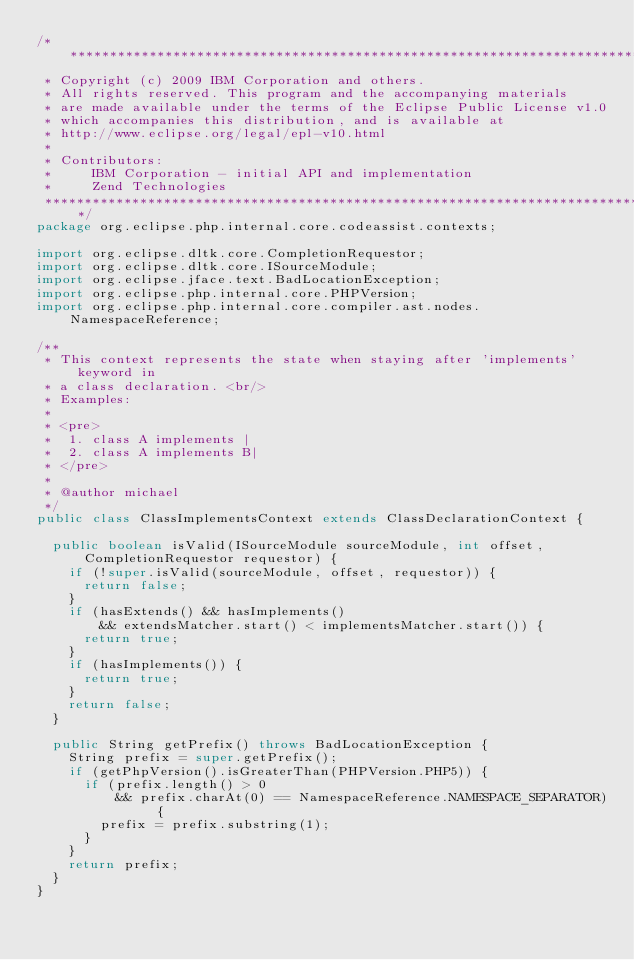Convert code to text. <code><loc_0><loc_0><loc_500><loc_500><_Java_>/*******************************************************************************
 * Copyright (c) 2009 IBM Corporation and others.
 * All rights reserved. This program and the accompanying materials
 * are made available under the terms of the Eclipse Public License v1.0
 * which accompanies this distribution, and is available at
 * http://www.eclipse.org/legal/epl-v10.html
 * 
 * Contributors:
 *     IBM Corporation - initial API and implementation
 *     Zend Technologies
 *******************************************************************************/
package org.eclipse.php.internal.core.codeassist.contexts;

import org.eclipse.dltk.core.CompletionRequestor;
import org.eclipse.dltk.core.ISourceModule;
import org.eclipse.jface.text.BadLocationException;
import org.eclipse.php.internal.core.PHPVersion;
import org.eclipse.php.internal.core.compiler.ast.nodes.NamespaceReference;

/**
 * This context represents the state when staying after 'implements' keyword in
 * a class declaration. <br/>
 * Examples:
 * 
 * <pre>
 *  1. class A implements |
 *  2. class A implements B|
 * </pre>
 * 
 * @author michael
 */
public class ClassImplementsContext extends ClassDeclarationContext {

	public boolean isValid(ISourceModule sourceModule, int offset,
			CompletionRequestor requestor) {
		if (!super.isValid(sourceModule, offset, requestor)) {
			return false;
		}
		if (hasExtends() && hasImplements()
				&& extendsMatcher.start() < implementsMatcher.start()) {
			return true;
		}
		if (hasImplements()) {
			return true;
		}
		return false;
	}

	public String getPrefix() throws BadLocationException {
		String prefix = super.getPrefix();
		if (getPhpVersion().isGreaterThan(PHPVersion.PHP5)) {
			if (prefix.length() > 0
					&& prefix.charAt(0) == NamespaceReference.NAMESPACE_SEPARATOR) {
				prefix = prefix.substring(1);
			}
		}
		return prefix;
	}
}
</code> 